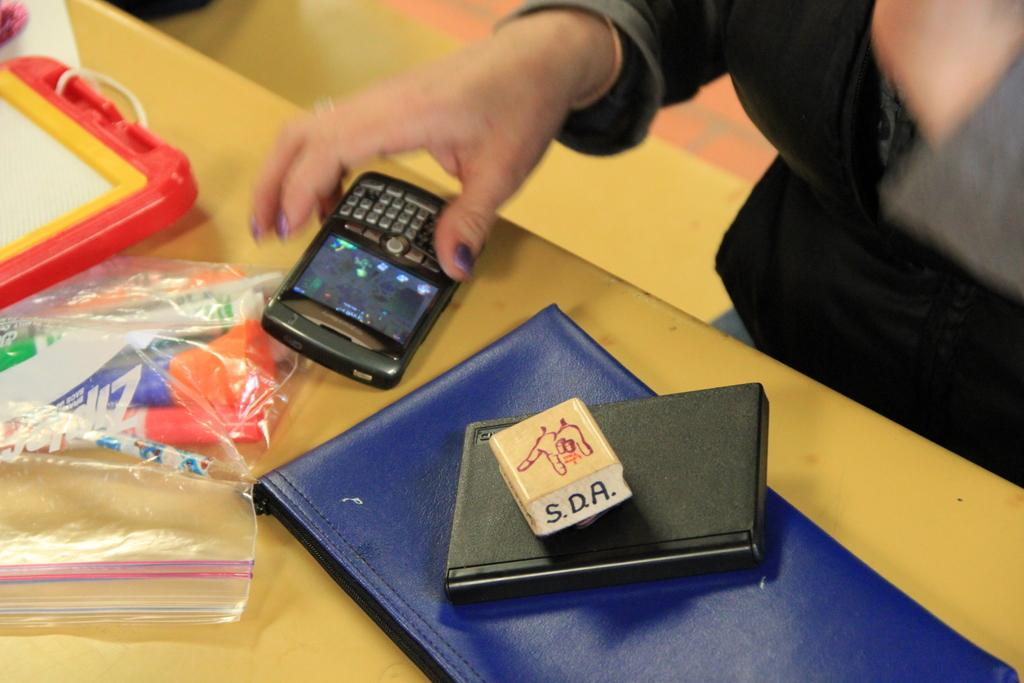Provide a one-sentence caption for the provided image. A person places their Blackberry phone down next to a Ziploc bag and a pile of books. 